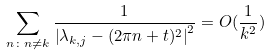Convert formula to latex. <formula><loc_0><loc_0><loc_500><loc_500>\sum _ { n \colon n \neq k } \frac { 1 } { \left | \lambda _ { k , j } - ( 2 \pi n + t ) ^ { 2 } \right | ^ { 2 } } = O ( \frac { 1 } { k ^ { 2 } } )</formula> 